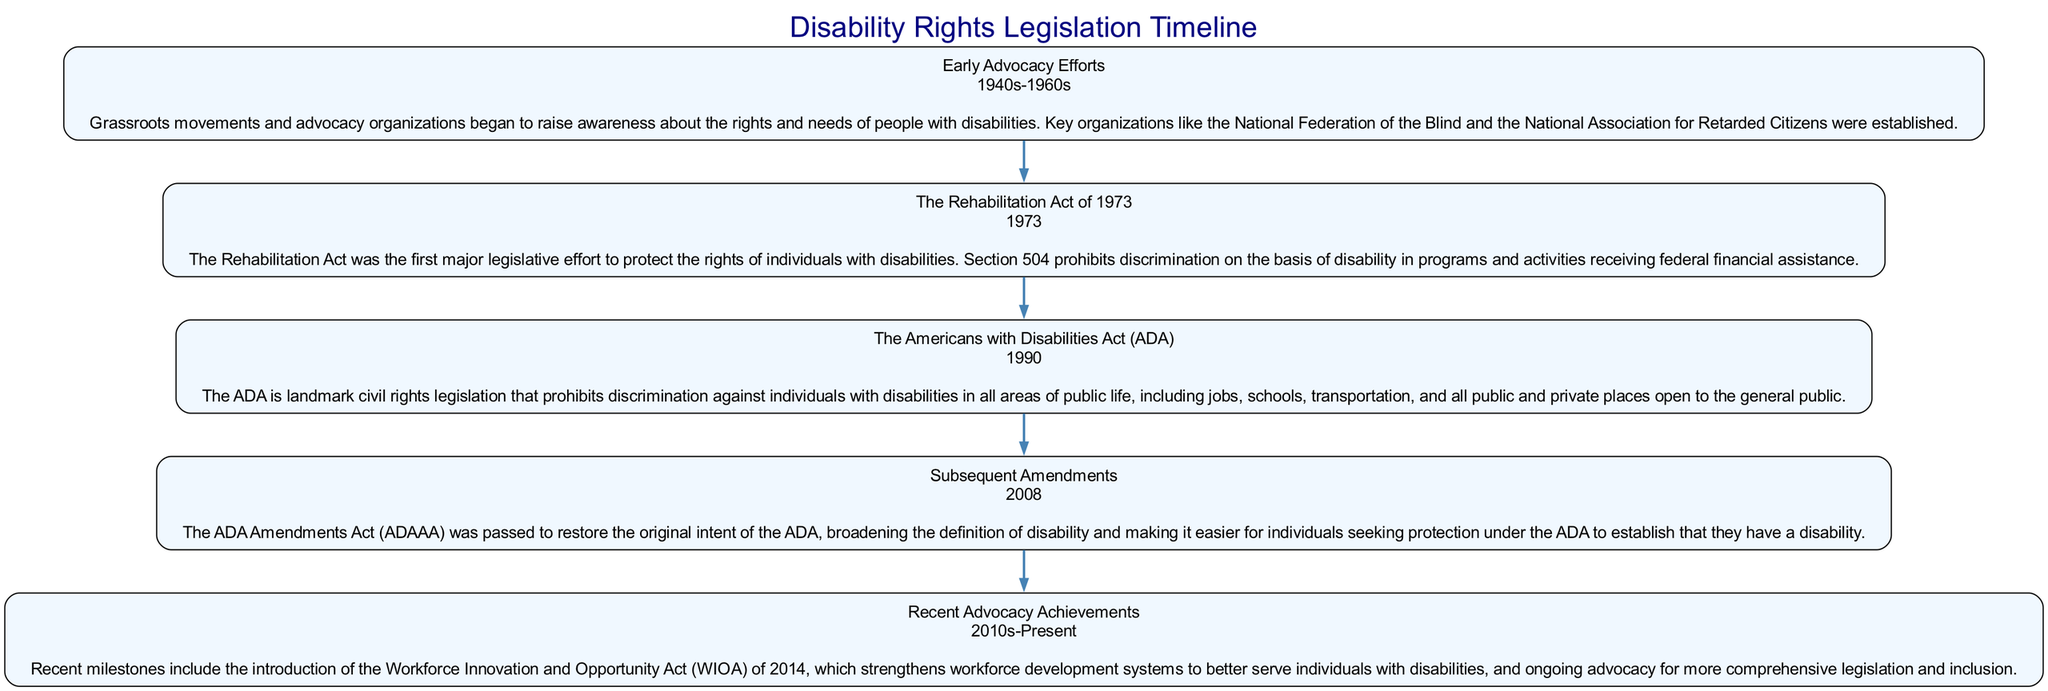What is the year associated with the Rehabilitation Act? The block related to the Rehabilitation Act of 1973 specifies the year as 1973.
Answer: 1973 How many blocks are in the diagram? Counting the number of blocks listed, there are five blocks: Early Advocacy Efforts, The Rehabilitation Act of 1973, The Americans with Disabilities Act, Subsequent Amendments, and Recent Advocacy Achievements.
Answer: 5 What key legislation was passed in 1990? The block for the Americans with Disabilities Act explicitly states that it was passed in 1990.
Answer: Americans with Disabilities Act Which block follows the block on Early Advocacy Efforts? The diagram shows that The Rehabilitation Act of 1973 follows Early Advocacy Efforts as the second block.
Answer: The Rehabilitation Act of 1973 What was a significant change made by the ADA Amendments Act? The summary for Subsequent Amendments indicates that one significant change was to broaden the definition of disability under the ADA.
Answer: Broadened the definition of disability Which legislative milestone emphasizes workforce development for individuals with disabilities? The Recent Advocacy Achievements block mentions the Workforce Innovation and Opportunity Act of 2014, which emphasizes workforce development for individuals with disabilities.
Answer: Workforce Innovation and Opportunity Act How does the summary for the Americans with Disabilities Act relate to public life? The summary for the Americans with Disabilities Act states that it prohibits discrimination against individuals with disabilities in all areas of public life, making it a fundamental piece of civil rights legislation.
Answer: Prohibits discrimination in public life What relationship exists between the Rehabilitation Act and federal funding? The summary for the Rehabilitation Act states that Section 504 prohibits discrimination based on disability in programs and activities that receive federal financial assistance, establishing a direct link to federal funding.
Answer: Prohibits discrimination in federally funded programs What time period does the block for Early Advocacy Efforts cover? The block for Early Advocacy Efforts specifies that it covers the 1940s to the 1960s.
Answer: 1940s-1960s 